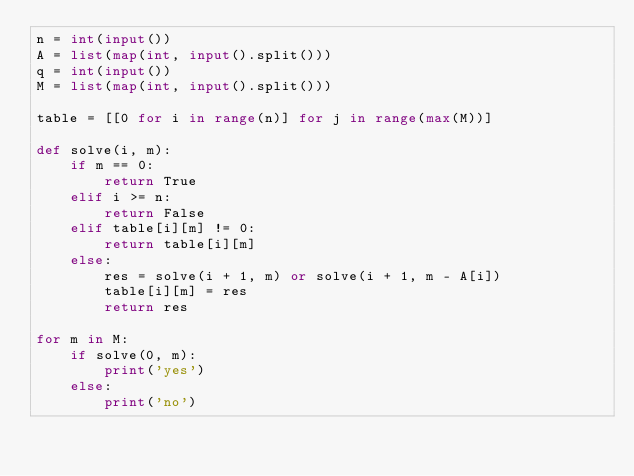Convert code to text. <code><loc_0><loc_0><loc_500><loc_500><_Python_>n = int(input())
A = list(map(int, input().split()))
q = int(input())
M = list(map(int, input().split()))

table = [[0 for i in range(n)] for j in range(max(M))]

def solve(i, m): 
    if m == 0:
        return True
    elif i >= n:
        return False
    elif table[i][m] != 0:
        return table[i][m]
    else:
        res = solve(i + 1, m) or solve(i + 1, m - A[i])
        table[i][m] = res
        return res

for m in M:
    if solve(0, m):
        print('yes')
    else:
        print('no')</code> 